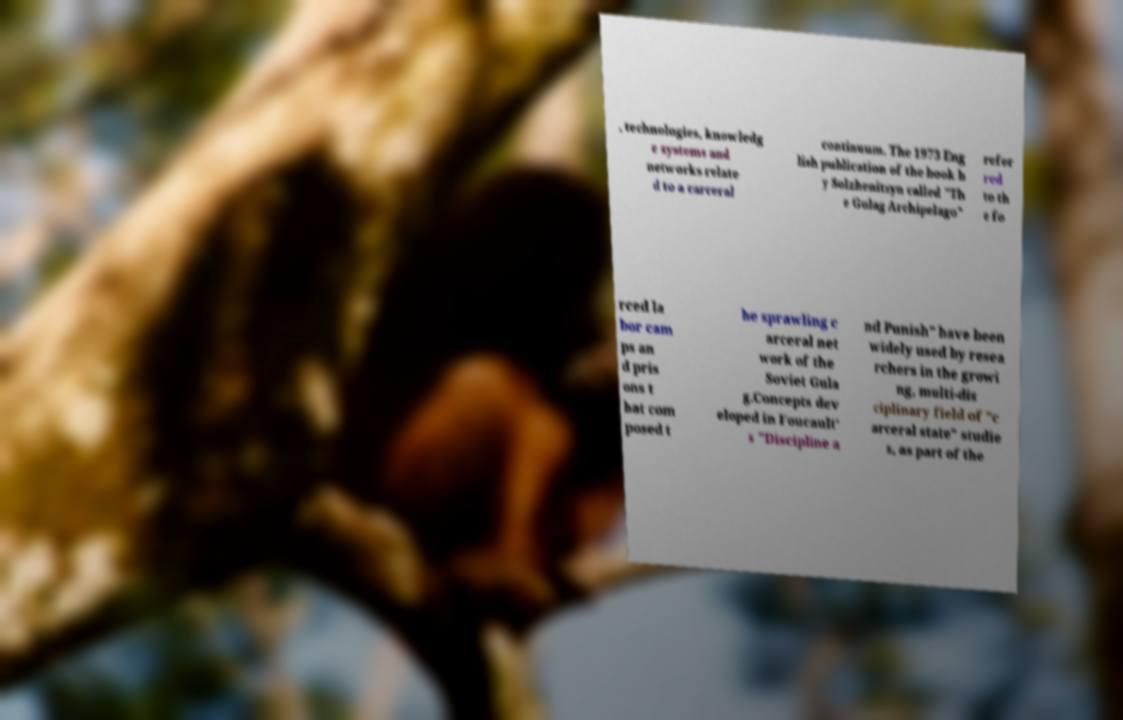For documentation purposes, I need the text within this image transcribed. Could you provide that? , technologies, knowledg e systems and networks relate d to a carceral continuum. The 1973 Eng lish publication of the book b y Solzhenitsyn called "Th e Gulag Archipelago" refer red to th e fo rced la bor cam ps an d pris ons t hat com posed t he sprawling c arceral net work of the Soviet Gula g.Concepts dev eloped in Foucault' s "Discipline a nd Punish" have been widely used by resea rchers in the growi ng, multi-dis ciplinary field of "c arceral state" studie s, as part of the 